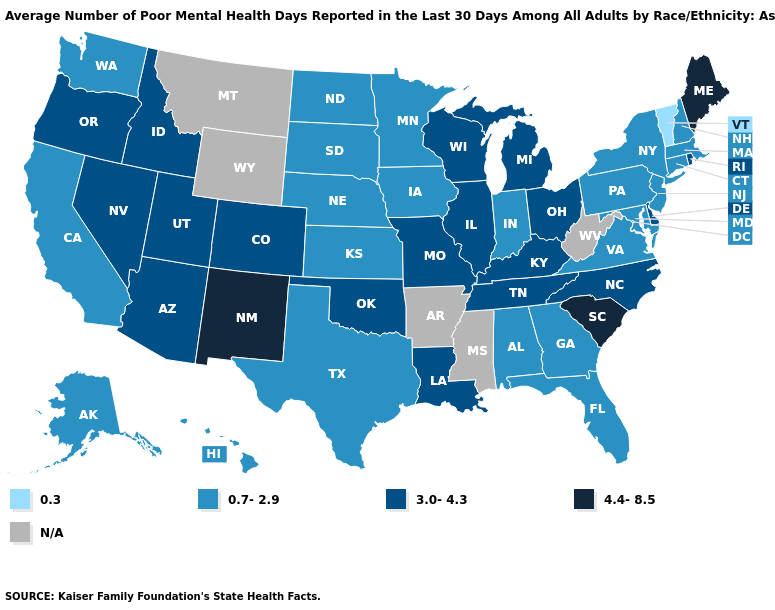Name the states that have a value in the range N/A?
Write a very short answer. Arkansas, Mississippi, Montana, West Virginia, Wyoming. What is the value of Georgia?
Keep it brief. 0.7-2.9. Name the states that have a value in the range 0.7-2.9?
Answer briefly. Alabama, Alaska, California, Connecticut, Florida, Georgia, Hawaii, Indiana, Iowa, Kansas, Maryland, Massachusetts, Minnesota, Nebraska, New Hampshire, New Jersey, New York, North Dakota, Pennsylvania, South Dakota, Texas, Virginia, Washington. What is the lowest value in states that border West Virginia?
Write a very short answer. 0.7-2.9. Among the states that border Alabama , does Georgia have the lowest value?
Give a very brief answer. Yes. Does Minnesota have the lowest value in the MidWest?
Be succinct. Yes. What is the value of Montana?
Concise answer only. N/A. What is the highest value in states that border Louisiana?
Write a very short answer. 0.7-2.9. Does New Hampshire have the highest value in the USA?
Short answer required. No. What is the lowest value in the USA?
Be succinct. 0.3. What is the value of Missouri?
Quick response, please. 3.0-4.3. Which states have the lowest value in the USA?
Give a very brief answer. Vermont. Among the states that border Arkansas , which have the highest value?
Keep it brief. Louisiana, Missouri, Oklahoma, Tennessee. 